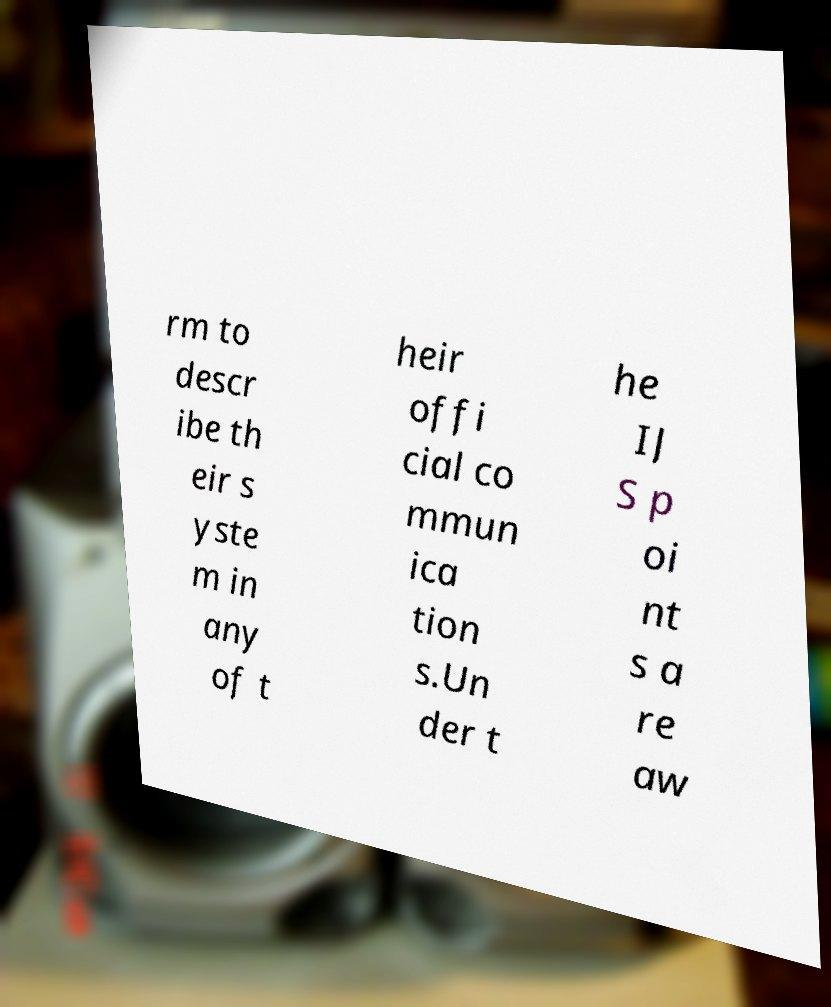Could you assist in decoding the text presented in this image and type it out clearly? rm to descr ibe th eir s yste m in any of t heir offi cial co mmun ica tion s.Un der t he IJ S p oi nt s a re aw 